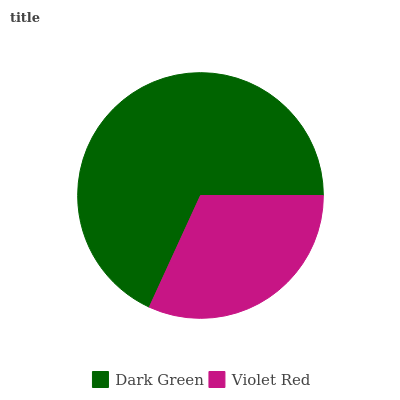Is Violet Red the minimum?
Answer yes or no. Yes. Is Dark Green the maximum?
Answer yes or no. Yes. Is Violet Red the maximum?
Answer yes or no. No. Is Dark Green greater than Violet Red?
Answer yes or no. Yes. Is Violet Red less than Dark Green?
Answer yes or no. Yes. Is Violet Red greater than Dark Green?
Answer yes or no. No. Is Dark Green less than Violet Red?
Answer yes or no. No. Is Dark Green the high median?
Answer yes or no. Yes. Is Violet Red the low median?
Answer yes or no. Yes. Is Violet Red the high median?
Answer yes or no. No. Is Dark Green the low median?
Answer yes or no. No. 